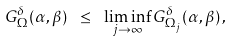Convert formula to latex. <formula><loc_0><loc_0><loc_500><loc_500>G _ { \Omega } ^ { \delta } ( \alpha , \beta ) \ \leq \ \liminf _ { j \rightarrow \infty } G _ { \Omega _ { j } } ^ { \delta } ( \alpha , \beta ) \, ,</formula> 